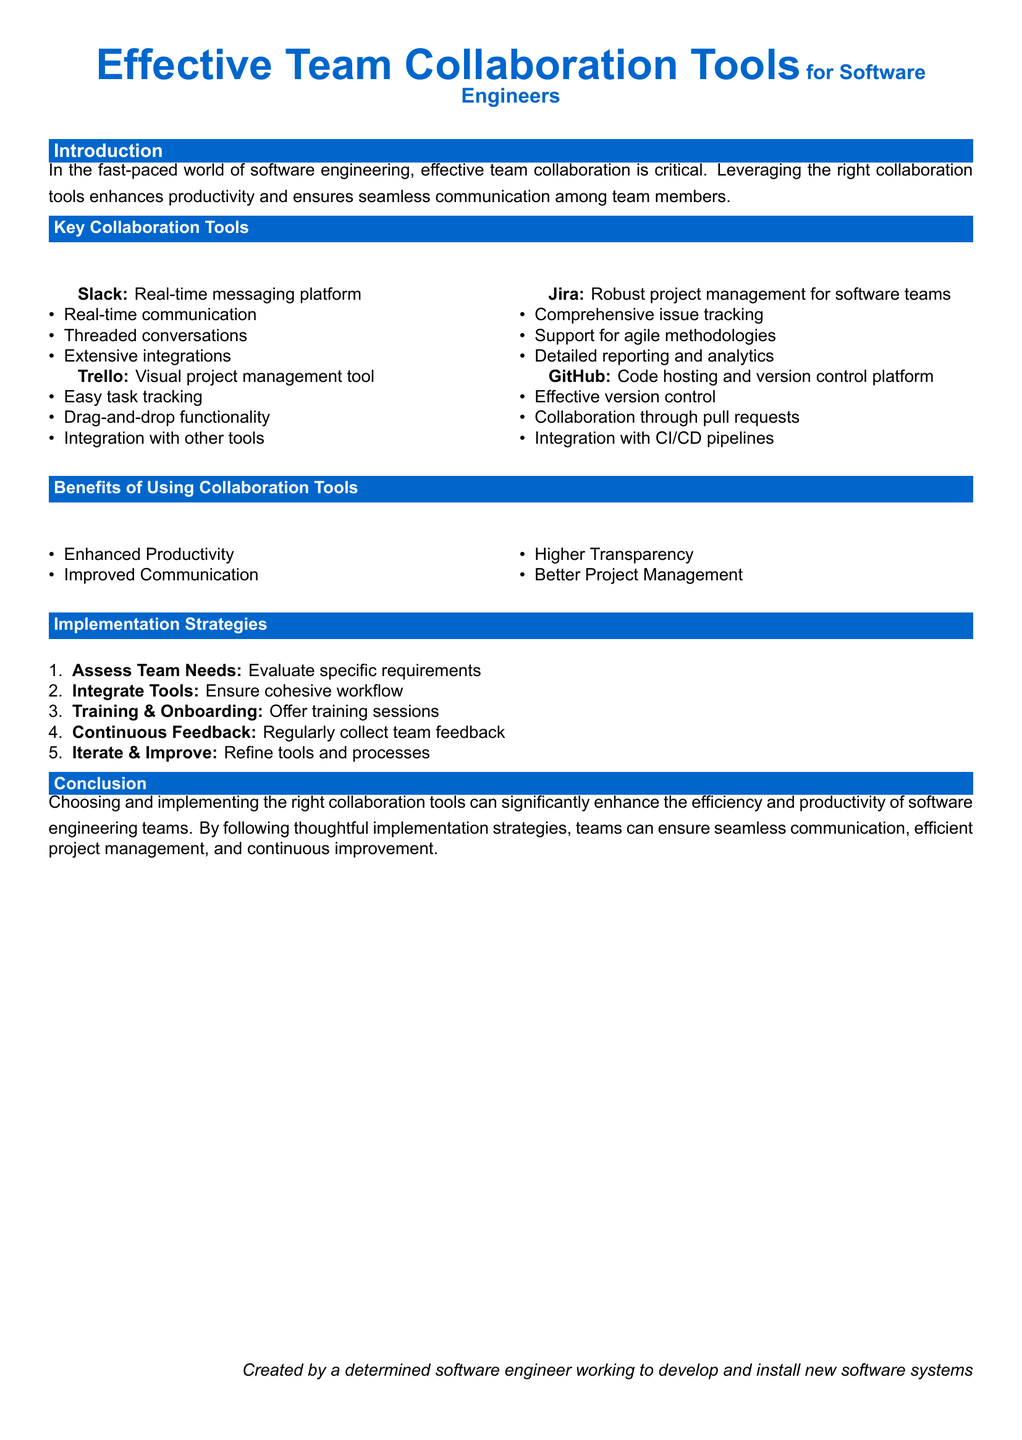What is the title of the document? The title of the document is presented prominently at the top and describes the main subject.
Answer: Effective Team Collaboration Tools How many key collaboration tools are listed? The document includes a section specifically listing collaboration tools, and the count is noted.
Answer: Four What is the main benefit of using collaboration tools? The document outlines benefits, and the first listed is a primary advantage.
Answer: Enhanced Productivity Which platform is known for real-time messaging? The document mentions specific tools and their functionalities, identifying one as a messaging platform.
Answer: Slack What is the first implementation strategy mentioned? The document presents implementation strategies in a numbered list, and the first point provides a specific action.
Answer: Assess Team Needs Which tool supports agile methodologies? The document specifies a collaboration tool that is particularly suited to agile project management.
Answer: Jira What color is the background of the document? The document primarily describes the visual aspects, including the background color.
Answer: White How many advantages of using collaboration tools are listed? The document explicitly lists several benefits, and counting yields the total number.
Answer: Four 